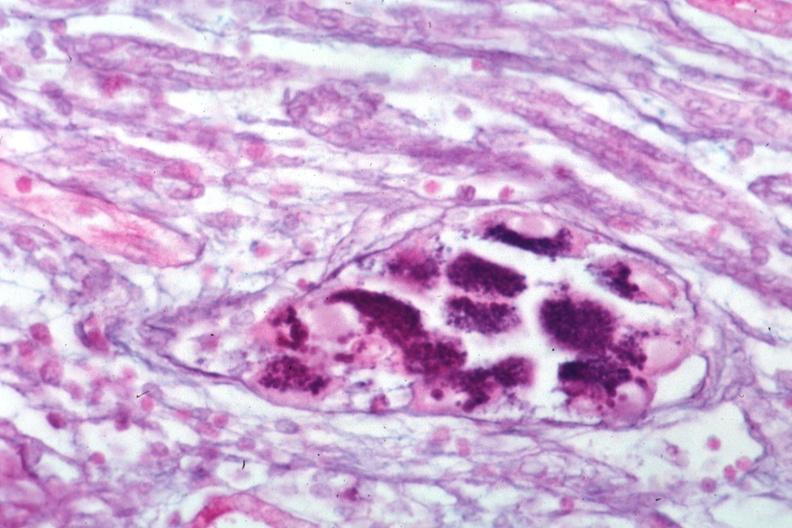where is this?
Answer the question using a single word or phrase. Urinary 